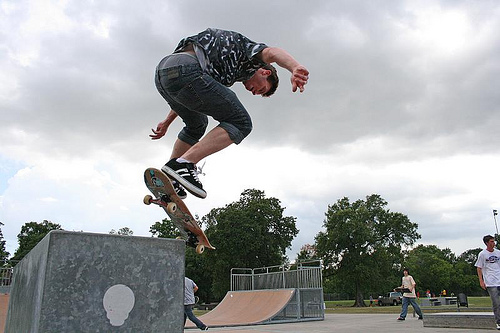<image>
Is the skateboard to the left of the ramp? Yes. From this viewpoint, the skateboard is positioned to the left side relative to the ramp. 